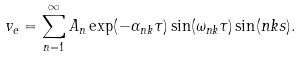Convert formula to latex. <formula><loc_0><loc_0><loc_500><loc_500>v _ { e } = \sum _ { n = 1 } ^ { \infty } A _ { n } \exp ( - \alpha _ { n k } \tau ) \sin ( \omega _ { n k } \tau ) \sin ( n k s ) .</formula> 